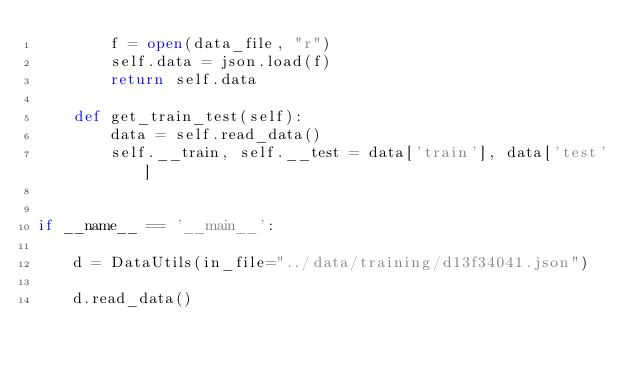Convert code to text. <code><loc_0><loc_0><loc_500><loc_500><_Python_>        f = open(data_file, "r")
        self.data = json.load(f)
        return self.data

    def get_train_test(self):
        data = self.read_data()
        self.__train, self.__test = data['train'], data['test']


if __name__ == '__main__':

    d = DataUtils(in_file="../data/training/d13f34041.json")

    d.read_data()
</code> 